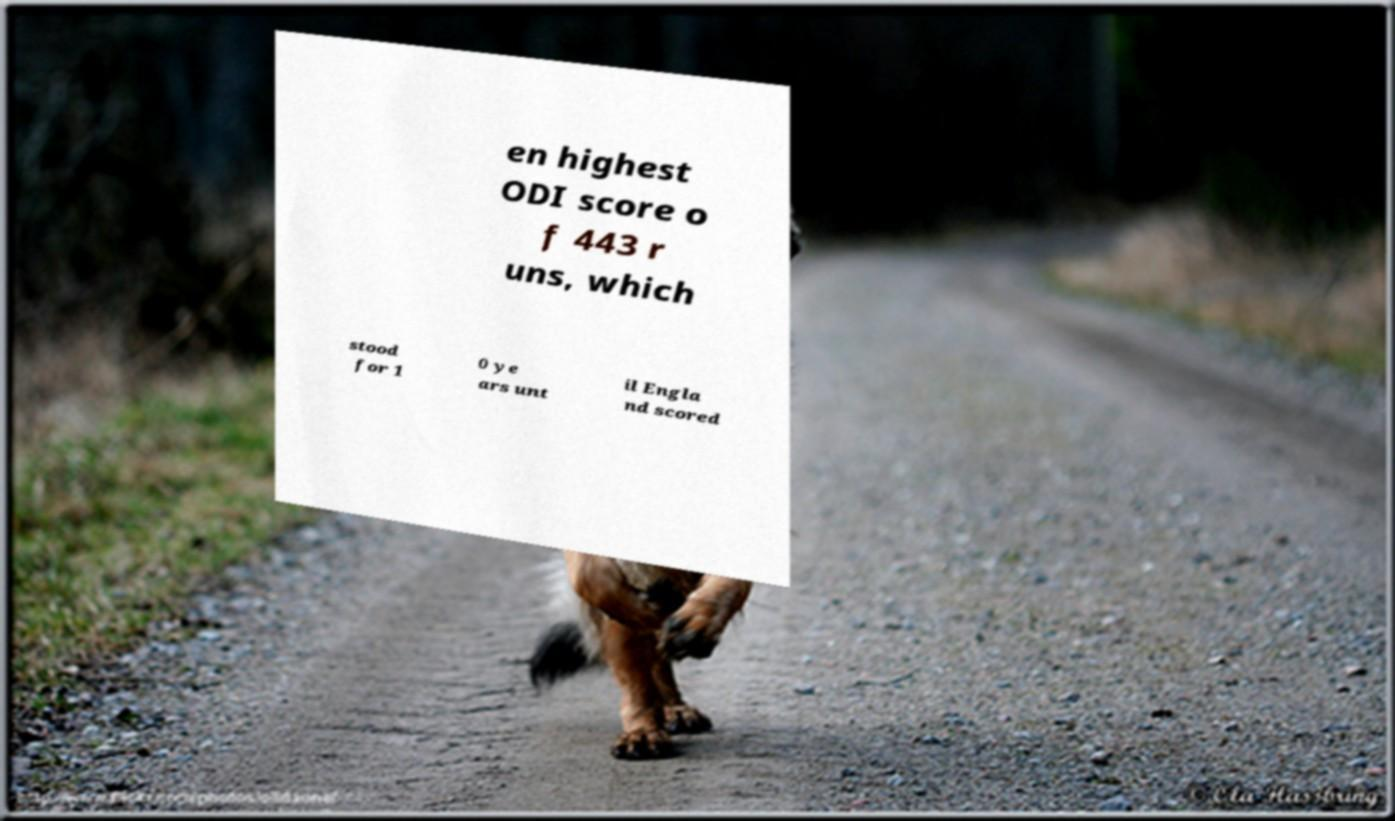For documentation purposes, I need the text within this image transcribed. Could you provide that? en highest ODI score o f 443 r uns, which stood for 1 0 ye ars unt il Engla nd scored 